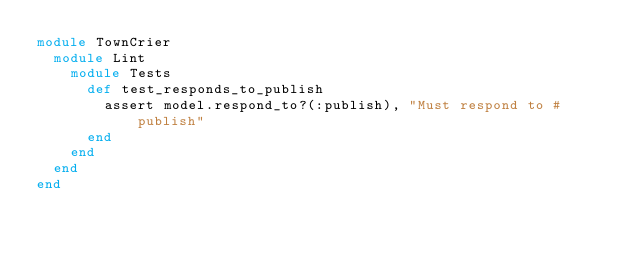Convert code to text. <code><loc_0><loc_0><loc_500><loc_500><_Ruby_>module TownCrier
  module Lint
    module Tests
      def test_responds_to_publish
        assert model.respond_to?(:publish), "Must respond to #publish"
      end
    end
  end
end
</code> 